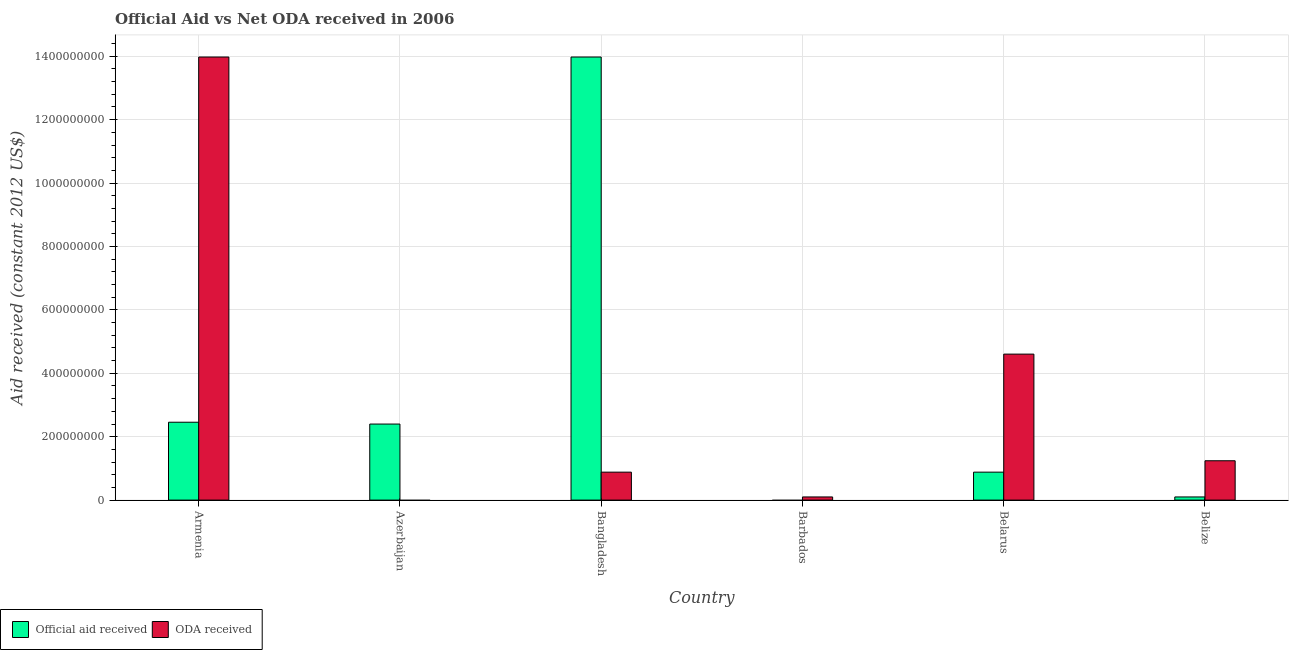How many different coloured bars are there?
Ensure brevity in your answer.  2. How many bars are there on the 4th tick from the left?
Ensure brevity in your answer.  1. What is the label of the 6th group of bars from the left?
Keep it short and to the point. Belize. What is the official aid received in Azerbaijan?
Ensure brevity in your answer.  2.40e+08. Across all countries, what is the maximum official aid received?
Your response must be concise. 1.40e+09. What is the total oda received in the graph?
Give a very brief answer. 2.08e+09. What is the difference between the oda received in Belarus and that in Belize?
Provide a succinct answer. 3.36e+08. What is the difference between the official aid received in Belarus and the oda received in Azerbaijan?
Your response must be concise. 8.82e+07. What is the average oda received per country?
Provide a succinct answer. 3.47e+08. What is the difference between the official aid received and oda received in Bangladesh?
Make the answer very short. 1.31e+09. What is the ratio of the official aid received in Bangladesh to that in Belarus?
Make the answer very short. 15.85. Is the difference between the official aid received in Belarus and Belize greater than the difference between the oda received in Belarus and Belize?
Your response must be concise. No. What is the difference between the highest and the second highest oda received?
Provide a succinct answer. 9.37e+08. What is the difference between the highest and the lowest official aid received?
Offer a terse response. 1.40e+09. In how many countries, is the official aid received greater than the average official aid received taken over all countries?
Your answer should be very brief. 1. Is the sum of the oda received in Bangladesh and Barbados greater than the maximum official aid received across all countries?
Your answer should be compact. No. Are all the bars in the graph horizontal?
Offer a terse response. No. How many countries are there in the graph?
Offer a very short reply. 6. What is the difference between two consecutive major ticks on the Y-axis?
Your response must be concise. 2.00e+08. What is the title of the graph?
Your answer should be very brief. Official Aid vs Net ODA received in 2006 . Does "Taxes on exports" appear as one of the legend labels in the graph?
Keep it short and to the point. No. What is the label or title of the X-axis?
Your answer should be compact. Country. What is the label or title of the Y-axis?
Make the answer very short. Aid received (constant 2012 US$). What is the Aid received (constant 2012 US$) in Official aid received in Armenia?
Give a very brief answer. 2.46e+08. What is the Aid received (constant 2012 US$) of ODA received in Armenia?
Your answer should be compact. 1.40e+09. What is the Aid received (constant 2012 US$) in Official aid received in Azerbaijan?
Offer a very short reply. 2.40e+08. What is the Aid received (constant 2012 US$) in ODA received in Azerbaijan?
Provide a succinct answer. 0. What is the Aid received (constant 2012 US$) in Official aid received in Bangladesh?
Keep it short and to the point. 1.40e+09. What is the Aid received (constant 2012 US$) of ODA received in Bangladesh?
Your response must be concise. 8.82e+07. What is the Aid received (constant 2012 US$) in ODA received in Barbados?
Ensure brevity in your answer.  9.93e+06. What is the Aid received (constant 2012 US$) of Official aid received in Belarus?
Ensure brevity in your answer.  8.82e+07. What is the Aid received (constant 2012 US$) of ODA received in Belarus?
Provide a succinct answer. 4.60e+08. What is the Aid received (constant 2012 US$) of Official aid received in Belize?
Offer a very short reply. 9.93e+06. What is the Aid received (constant 2012 US$) in ODA received in Belize?
Your answer should be compact. 1.24e+08. Across all countries, what is the maximum Aid received (constant 2012 US$) of Official aid received?
Your answer should be compact. 1.40e+09. Across all countries, what is the maximum Aid received (constant 2012 US$) in ODA received?
Your answer should be very brief. 1.40e+09. Across all countries, what is the minimum Aid received (constant 2012 US$) in Official aid received?
Make the answer very short. 0. Across all countries, what is the minimum Aid received (constant 2012 US$) in ODA received?
Make the answer very short. 0. What is the total Aid received (constant 2012 US$) in Official aid received in the graph?
Your response must be concise. 1.98e+09. What is the total Aid received (constant 2012 US$) of ODA received in the graph?
Your answer should be very brief. 2.08e+09. What is the difference between the Aid received (constant 2012 US$) of Official aid received in Armenia and that in Azerbaijan?
Offer a terse response. 5.78e+06. What is the difference between the Aid received (constant 2012 US$) of Official aid received in Armenia and that in Bangladesh?
Give a very brief answer. -1.15e+09. What is the difference between the Aid received (constant 2012 US$) of ODA received in Armenia and that in Bangladesh?
Give a very brief answer. 1.31e+09. What is the difference between the Aid received (constant 2012 US$) in ODA received in Armenia and that in Barbados?
Ensure brevity in your answer.  1.39e+09. What is the difference between the Aid received (constant 2012 US$) in Official aid received in Armenia and that in Belarus?
Make the answer very short. 1.57e+08. What is the difference between the Aid received (constant 2012 US$) of ODA received in Armenia and that in Belarus?
Offer a very short reply. 9.37e+08. What is the difference between the Aid received (constant 2012 US$) in Official aid received in Armenia and that in Belize?
Provide a short and direct response. 2.36e+08. What is the difference between the Aid received (constant 2012 US$) of ODA received in Armenia and that in Belize?
Keep it short and to the point. 1.27e+09. What is the difference between the Aid received (constant 2012 US$) in Official aid received in Azerbaijan and that in Bangladesh?
Make the answer very short. -1.16e+09. What is the difference between the Aid received (constant 2012 US$) in Official aid received in Azerbaijan and that in Belarus?
Make the answer very short. 1.52e+08. What is the difference between the Aid received (constant 2012 US$) in Official aid received in Azerbaijan and that in Belize?
Make the answer very short. 2.30e+08. What is the difference between the Aid received (constant 2012 US$) in ODA received in Bangladesh and that in Barbados?
Make the answer very short. 7.82e+07. What is the difference between the Aid received (constant 2012 US$) in Official aid received in Bangladesh and that in Belarus?
Provide a short and direct response. 1.31e+09. What is the difference between the Aid received (constant 2012 US$) in ODA received in Bangladesh and that in Belarus?
Give a very brief answer. -3.72e+08. What is the difference between the Aid received (constant 2012 US$) of Official aid received in Bangladesh and that in Belize?
Give a very brief answer. 1.39e+09. What is the difference between the Aid received (constant 2012 US$) in ODA received in Bangladesh and that in Belize?
Give a very brief answer. -3.59e+07. What is the difference between the Aid received (constant 2012 US$) of ODA received in Barbados and that in Belarus?
Provide a short and direct response. -4.51e+08. What is the difference between the Aid received (constant 2012 US$) in ODA received in Barbados and that in Belize?
Ensure brevity in your answer.  -1.14e+08. What is the difference between the Aid received (constant 2012 US$) of Official aid received in Belarus and that in Belize?
Provide a succinct answer. 7.82e+07. What is the difference between the Aid received (constant 2012 US$) of ODA received in Belarus and that in Belize?
Keep it short and to the point. 3.36e+08. What is the difference between the Aid received (constant 2012 US$) in Official aid received in Armenia and the Aid received (constant 2012 US$) in ODA received in Bangladesh?
Your answer should be compact. 1.57e+08. What is the difference between the Aid received (constant 2012 US$) of Official aid received in Armenia and the Aid received (constant 2012 US$) of ODA received in Barbados?
Make the answer very short. 2.36e+08. What is the difference between the Aid received (constant 2012 US$) in Official aid received in Armenia and the Aid received (constant 2012 US$) in ODA received in Belarus?
Provide a short and direct response. -2.15e+08. What is the difference between the Aid received (constant 2012 US$) of Official aid received in Armenia and the Aid received (constant 2012 US$) of ODA received in Belize?
Offer a terse response. 1.22e+08. What is the difference between the Aid received (constant 2012 US$) of Official aid received in Azerbaijan and the Aid received (constant 2012 US$) of ODA received in Bangladesh?
Your answer should be compact. 1.52e+08. What is the difference between the Aid received (constant 2012 US$) in Official aid received in Azerbaijan and the Aid received (constant 2012 US$) in ODA received in Barbados?
Your response must be concise. 2.30e+08. What is the difference between the Aid received (constant 2012 US$) of Official aid received in Azerbaijan and the Aid received (constant 2012 US$) of ODA received in Belarus?
Your answer should be compact. -2.21e+08. What is the difference between the Aid received (constant 2012 US$) in Official aid received in Azerbaijan and the Aid received (constant 2012 US$) in ODA received in Belize?
Your response must be concise. 1.16e+08. What is the difference between the Aid received (constant 2012 US$) of Official aid received in Bangladesh and the Aid received (constant 2012 US$) of ODA received in Barbados?
Your response must be concise. 1.39e+09. What is the difference between the Aid received (constant 2012 US$) of Official aid received in Bangladesh and the Aid received (constant 2012 US$) of ODA received in Belarus?
Keep it short and to the point. 9.37e+08. What is the difference between the Aid received (constant 2012 US$) of Official aid received in Bangladesh and the Aid received (constant 2012 US$) of ODA received in Belize?
Offer a terse response. 1.27e+09. What is the difference between the Aid received (constant 2012 US$) in Official aid received in Belarus and the Aid received (constant 2012 US$) in ODA received in Belize?
Your answer should be compact. -3.59e+07. What is the average Aid received (constant 2012 US$) in Official aid received per country?
Offer a terse response. 3.30e+08. What is the average Aid received (constant 2012 US$) in ODA received per country?
Provide a short and direct response. 3.47e+08. What is the difference between the Aid received (constant 2012 US$) of Official aid received and Aid received (constant 2012 US$) of ODA received in Armenia?
Ensure brevity in your answer.  -1.15e+09. What is the difference between the Aid received (constant 2012 US$) of Official aid received and Aid received (constant 2012 US$) of ODA received in Bangladesh?
Give a very brief answer. 1.31e+09. What is the difference between the Aid received (constant 2012 US$) in Official aid received and Aid received (constant 2012 US$) in ODA received in Belarus?
Offer a terse response. -3.72e+08. What is the difference between the Aid received (constant 2012 US$) of Official aid received and Aid received (constant 2012 US$) of ODA received in Belize?
Keep it short and to the point. -1.14e+08. What is the ratio of the Aid received (constant 2012 US$) in Official aid received in Armenia to that in Azerbaijan?
Make the answer very short. 1.02. What is the ratio of the Aid received (constant 2012 US$) in Official aid received in Armenia to that in Bangladesh?
Offer a very short reply. 0.18. What is the ratio of the Aid received (constant 2012 US$) in ODA received in Armenia to that in Bangladesh?
Make the answer very short. 15.85. What is the ratio of the Aid received (constant 2012 US$) of ODA received in Armenia to that in Barbados?
Provide a succinct answer. 140.74. What is the ratio of the Aid received (constant 2012 US$) in Official aid received in Armenia to that in Belarus?
Keep it short and to the point. 2.79. What is the ratio of the Aid received (constant 2012 US$) of ODA received in Armenia to that in Belarus?
Your answer should be very brief. 3.04. What is the ratio of the Aid received (constant 2012 US$) in Official aid received in Armenia to that in Belize?
Make the answer very short. 24.74. What is the ratio of the Aid received (constant 2012 US$) of ODA received in Armenia to that in Belize?
Keep it short and to the point. 11.26. What is the ratio of the Aid received (constant 2012 US$) of Official aid received in Azerbaijan to that in Bangladesh?
Offer a terse response. 0.17. What is the ratio of the Aid received (constant 2012 US$) in Official aid received in Azerbaijan to that in Belarus?
Offer a very short reply. 2.72. What is the ratio of the Aid received (constant 2012 US$) of Official aid received in Azerbaijan to that in Belize?
Provide a short and direct response. 24.16. What is the ratio of the Aid received (constant 2012 US$) in ODA received in Bangladesh to that in Barbados?
Your answer should be compact. 8.88. What is the ratio of the Aid received (constant 2012 US$) in Official aid received in Bangladesh to that in Belarus?
Your answer should be compact. 15.85. What is the ratio of the Aid received (constant 2012 US$) of ODA received in Bangladesh to that in Belarus?
Provide a short and direct response. 0.19. What is the ratio of the Aid received (constant 2012 US$) of Official aid received in Bangladesh to that in Belize?
Provide a succinct answer. 140.74. What is the ratio of the Aid received (constant 2012 US$) of ODA received in Bangladesh to that in Belize?
Ensure brevity in your answer.  0.71. What is the ratio of the Aid received (constant 2012 US$) of ODA received in Barbados to that in Belarus?
Ensure brevity in your answer.  0.02. What is the ratio of the Aid received (constant 2012 US$) in ODA received in Barbados to that in Belize?
Offer a terse response. 0.08. What is the ratio of the Aid received (constant 2012 US$) in Official aid received in Belarus to that in Belize?
Offer a very short reply. 8.88. What is the ratio of the Aid received (constant 2012 US$) in ODA received in Belarus to that in Belize?
Make the answer very short. 3.71. What is the difference between the highest and the second highest Aid received (constant 2012 US$) of Official aid received?
Provide a short and direct response. 1.15e+09. What is the difference between the highest and the second highest Aid received (constant 2012 US$) of ODA received?
Your answer should be compact. 9.37e+08. What is the difference between the highest and the lowest Aid received (constant 2012 US$) of Official aid received?
Keep it short and to the point. 1.40e+09. What is the difference between the highest and the lowest Aid received (constant 2012 US$) of ODA received?
Ensure brevity in your answer.  1.40e+09. 